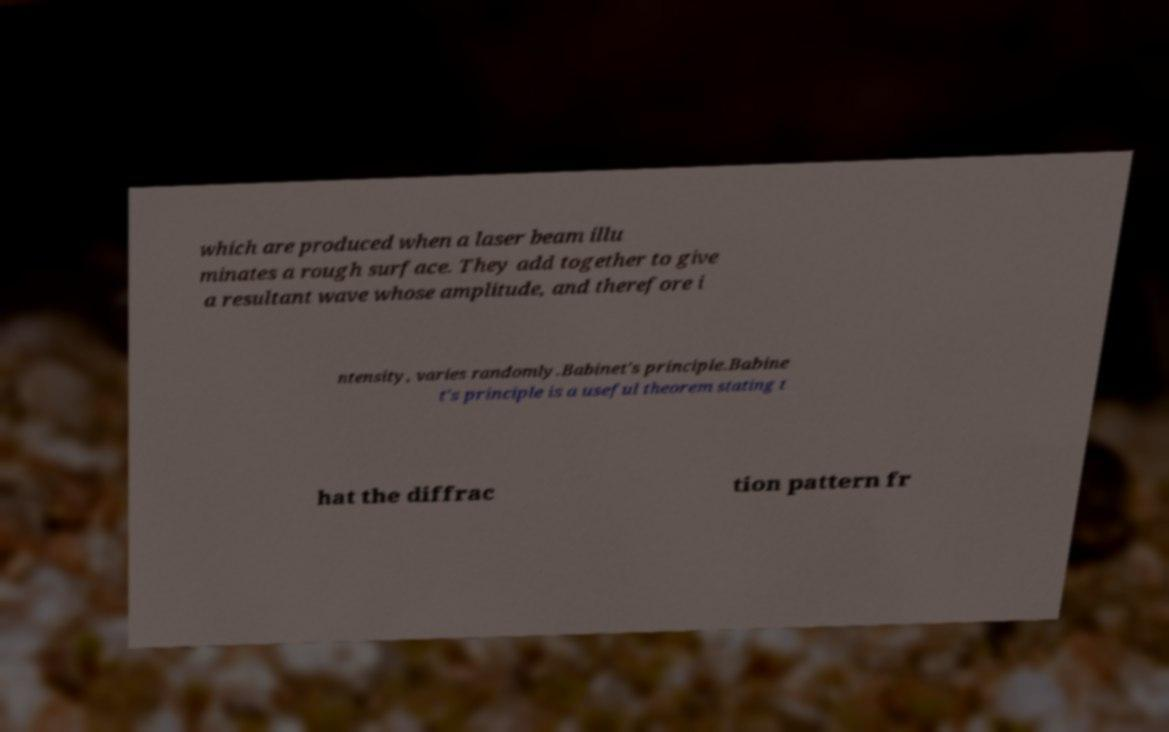There's text embedded in this image that I need extracted. Can you transcribe it verbatim? which are produced when a laser beam illu minates a rough surface. They add together to give a resultant wave whose amplitude, and therefore i ntensity, varies randomly.Babinet's principle.Babine t's principle is a useful theorem stating t hat the diffrac tion pattern fr 